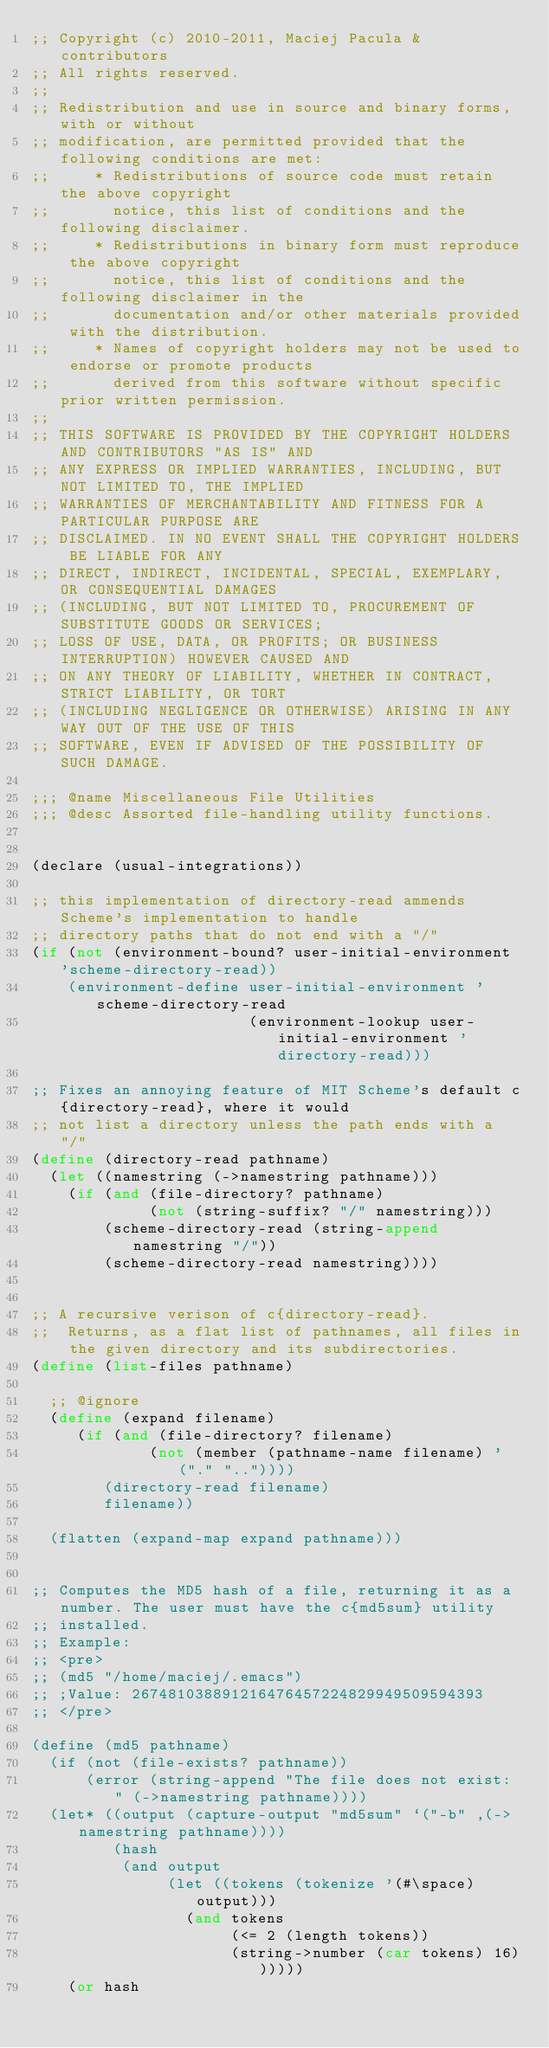Convert code to text. <code><loc_0><loc_0><loc_500><loc_500><_Scheme_>;; Copyright (c) 2010-2011, Maciej Pacula & contributors
;; All rights reserved.
;;
;; Redistribution and use in source and binary forms, with or without
;; modification, are permitted provided that the following conditions are met:
;;     * Redistributions of source code must retain the above copyright
;;       notice, this list of conditions and the following disclaimer.
;;     * Redistributions in binary form must reproduce the above copyright
;;       notice, this list of conditions and the following disclaimer in the
;;       documentation and/or other materials provided with the distribution.
;;     * Names of copyright holders may not be used to endorse or promote products
;;       derived from this software without specific prior written permission.
;;
;; THIS SOFTWARE IS PROVIDED BY THE COPYRIGHT HOLDERS AND CONTRIBUTORS "AS IS" AND
;; ANY EXPRESS OR IMPLIED WARRANTIES, INCLUDING, BUT NOT LIMITED TO, THE IMPLIED
;; WARRANTIES OF MERCHANTABILITY AND FITNESS FOR A PARTICULAR PURPOSE ARE
;; DISCLAIMED. IN NO EVENT SHALL THE COPYRIGHT HOLDERS BE LIABLE FOR ANY
;; DIRECT, INDIRECT, INCIDENTAL, SPECIAL, EXEMPLARY, OR CONSEQUENTIAL DAMAGES
;; (INCLUDING, BUT NOT LIMITED TO, PROCUREMENT OF SUBSTITUTE GOODS OR SERVICES;
;; LOSS OF USE, DATA, OR PROFITS; OR BUSINESS INTERRUPTION) HOWEVER CAUSED AND
;; ON ANY THEORY OF LIABILITY, WHETHER IN CONTRACT, STRICT LIABILITY, OR TORT
;; (INCLUDING NEGLIGENCE OR OTHERWISE) ARISING IN ANY WAY OUT OF THE USE OF THIS
;; SOFTWARE, EVEN IF ADVISED OF THE POSSIBILITY OF SUCH DAMAGE.

;;; @name Miscellaneous File Utilities
;;; @desc Assorted file-handling utility functions.


(declare (usual-integrations))

;; this implementation of directory-read ammends Scheme's implementation to handle
;; directory paths that do not end with a "/"
(if (not (environment-bound? user-initial-environment 'scheme-directory-read))
    (environment-define user-initial-environment 'scheme-directory-read
                        (environment-lookup user-initial-environment 'directory-read)))

;; Fixes an annoying feature of MIT Scheme's default c{directory-read}, where it would
;; not list a directory unless the path ends with a "/"
(define (directory-read pathname)
  (let ((namestring (->namestring pathname)))
    (if (and (file-directory? pathname)
             (not (string-suffix? "/" namestring)))
        (scheme-directory-read (string-append namestring "/"))
        (scheme-directory-read namestring))))


;; A recursive verison of c{directory-read}.
;;  Returns, as a flat list of pathnames, all files in the given directory and its subdirectories.
(define (list-files pathname)
 
  ;; @ignore
  (define (expand filename)
     (if (and (file-directory? filename)
             (not (member (pathname-name filename) '("." ".."))))
        (directory-read filename)
        filename))

  (flatten (expand-map expand pathname)))


;; Computes the MD5 hash of a file, returning it as a number. The user must have the c{md5sum} utility
;; installed.
;; Example:
;; <pre>
;; (md5 "/home/maciej/.emacs")
;; ;Value: 267481038891216476457224829949509594393
;; </pre>

(define (md5 pathname)
  (if (not (file-exists? pathname))
      (error (string-append "The file does not exist: " (->namestring pathname))))
  (let* ((output (capture-output "md5sum" `("-b" ,(->namestring pathname))))
         (hash
          (and output
               (let ((tokens (tokenize '(#\space) output)))
                 (and tokens
                      (<= 2 (length tokens))
                      (string->number (car tokens) 16))))))
    (or hash</code> 